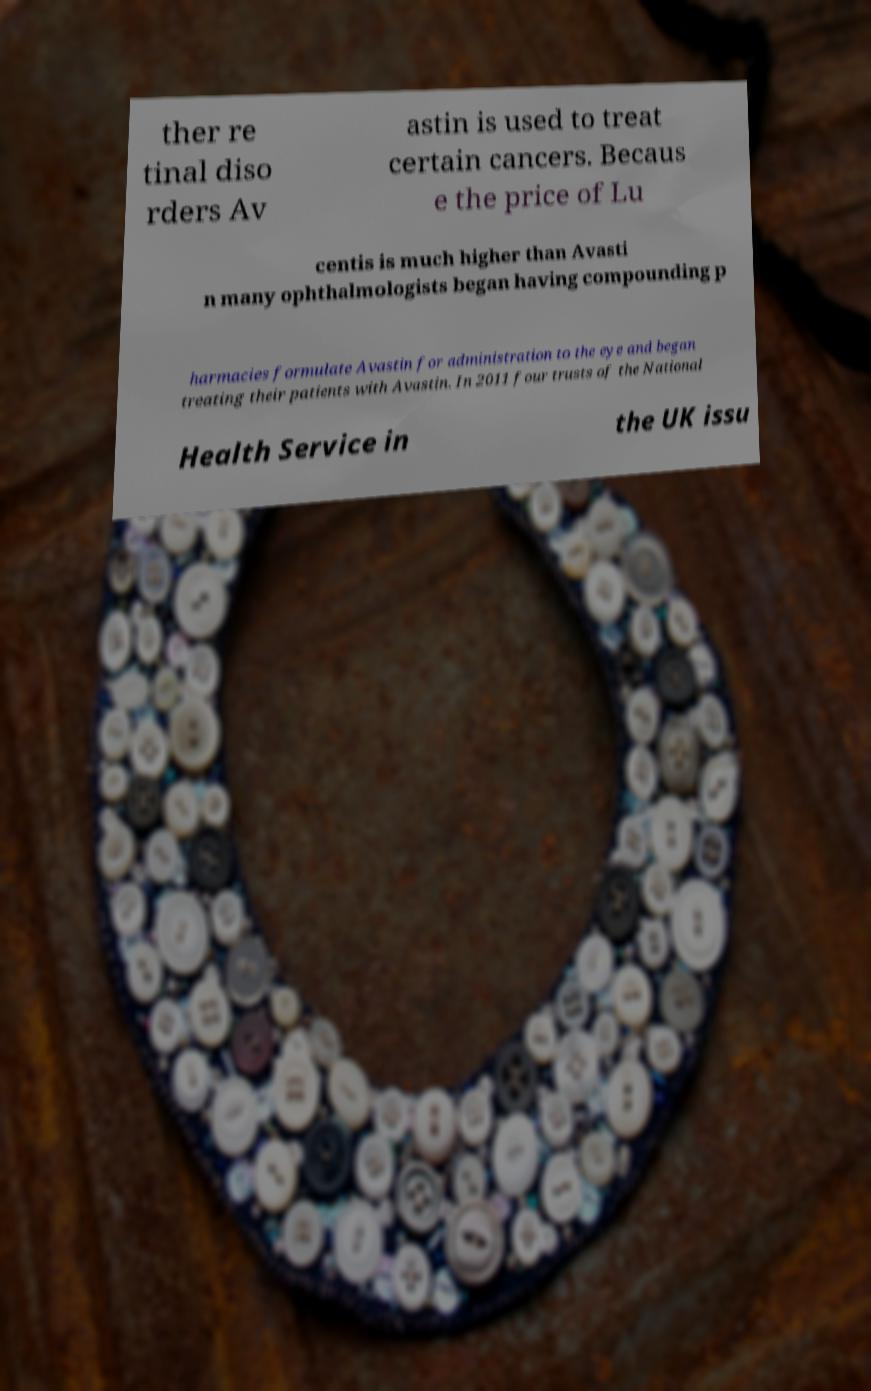Could you assist in decoding the text presented in this image and type it out clearly? ther re tinal diso rders Av astin is used to treat certain cancers. Becaus e the price of Lu centis is much higher than Avasti n many ophthalmologists began having compounding p harmacies formulate Avastin for administration to the eye and began treating their patients with Avastin. In 2011 four trusts of the National Health Service in the UK issu 